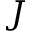Convert formula to latex. <formula><loc_0><loc_0><loc_500><loc_500>J</formula> 